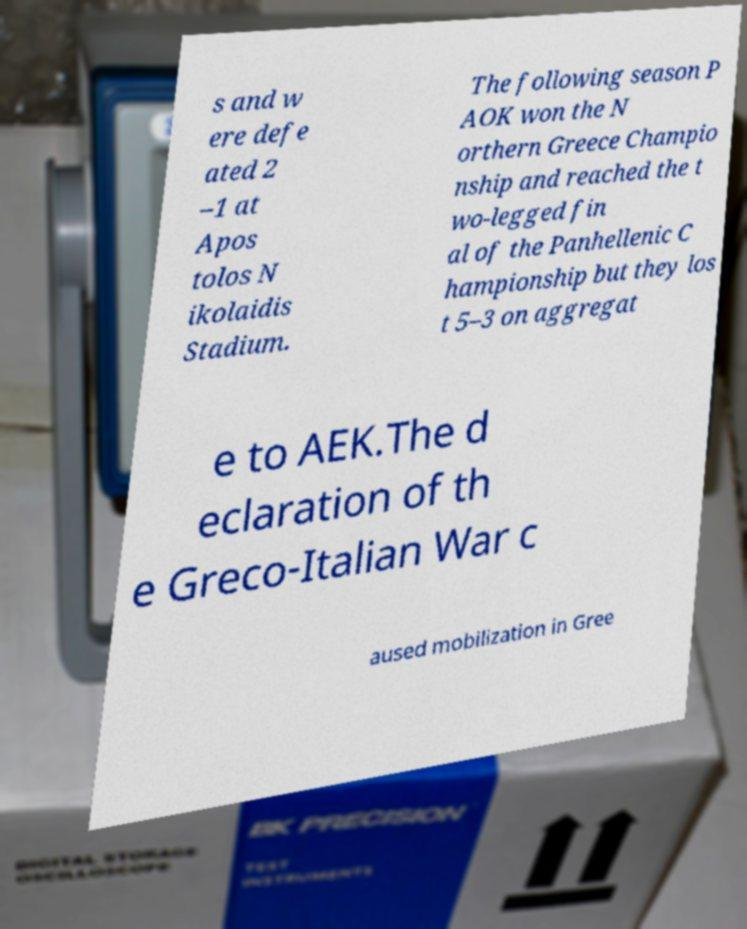Could you assist in decoding the text presented in this image and type it out clearly? s and w ere defe ated 2 –1 at Apos tolos N ikolaidis Stadium. The following season P AOK won the N orthern Greece Champio nship and reached the t wo-legged fin al of the Panhellenic C hampionship but they los t 5–3 on aggregat e to AEK.The d eclaration of th e Greco-Italian War c aused mobilization in Gree 